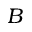<formula> <loc_0><loc_0><loc_500><loc_500>B</formula> 